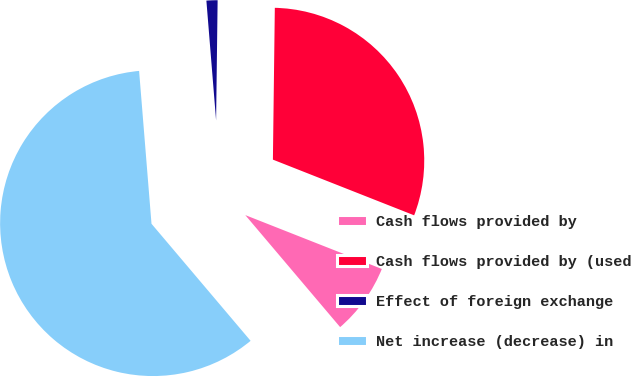Convert chart. <chart><loc_0><loc_0><loc_500><loc_500><pie_chart><fcel>Cash flows provided by<fcel>Cash flows provided by (used<fcel>Effect of foreign exchange<fcel>Net increase (decrease) in<nl><fcel>7.84%<fcel>30.78%<fcel>1.49%<fcel>59.9%<nl></chart> 